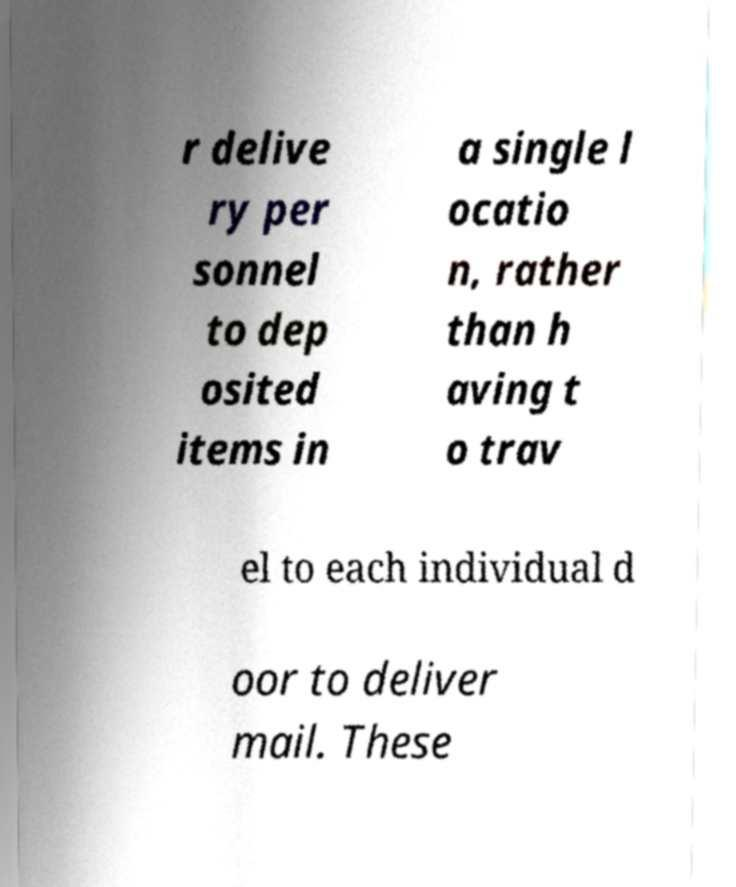For documentation purposes, I need the text within this image transcribed. Could you provide that? r delive ry per sonnel to dep osited items in a single l ocatio n, rather than h aving t o trav el to each individual d oor to deliver mail. These 